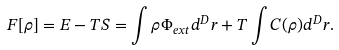Convert formula to latex. <formula><loc_0><loc_0><loc_500><loc_500>F [ \rho ] = E - T S = \int \rho \Phi _ { e x t } d ^ { D } { r } + T \int C ( \rho ) d ^ { D } { r } .</formula> 